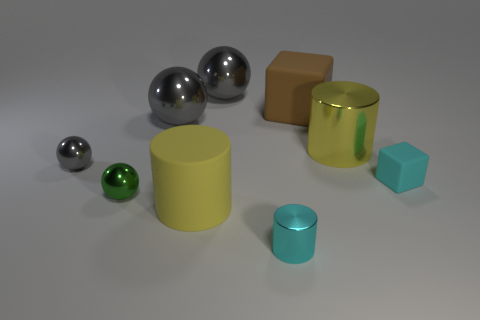How many gray spheres must be subtracted to get 1 gray spheres? 2 Subtract all gray cylinders. How many gray spheres are left? 3 Add 1 yellow shiny cylinders. How many objects exist? 10 Subtract all cubes. How many objects are left? 7 Subtract all gray metallic cubes. Subtract all tiny rubber objects. How many objects are left? 8 Add 5 large brown things. How many large brown things are left? 6 Add 7 big yellow things. How many big yellow things exist? 9 Subtract 1 cyan cubes. How many objects are left? 8 